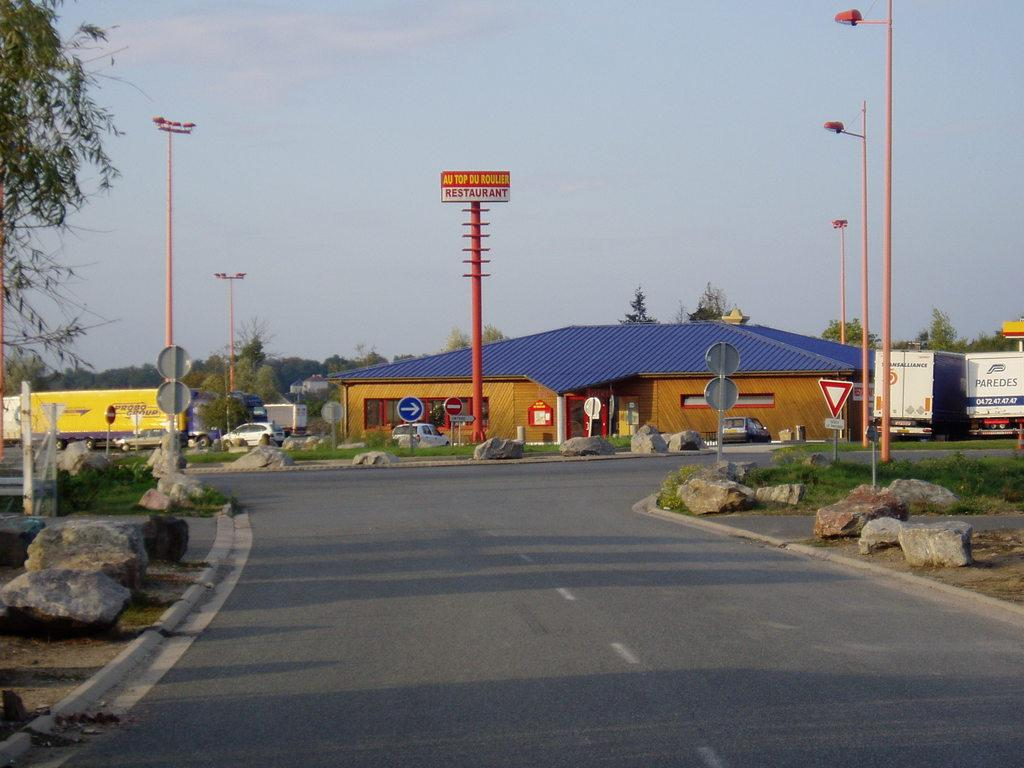What type of surface can be seen in the image? There is a road in the image. What natural elements are present in the image? There are rocks, trees, and grass in the image. What man-made structures can be seen in the image? There are poles, lights, boards, and buildings in the image. What is visible in the background of the image? The sky is visible in the background of the image. Can you see any bones sticking out of the rocks in the image? There are no bones visible in the image, and the rocks do not have any bones sticking out of them. What type of stick is being used by the trees in the image? There are no sticks being used by the trees in the image; the trees are simply standing in the landscape. 